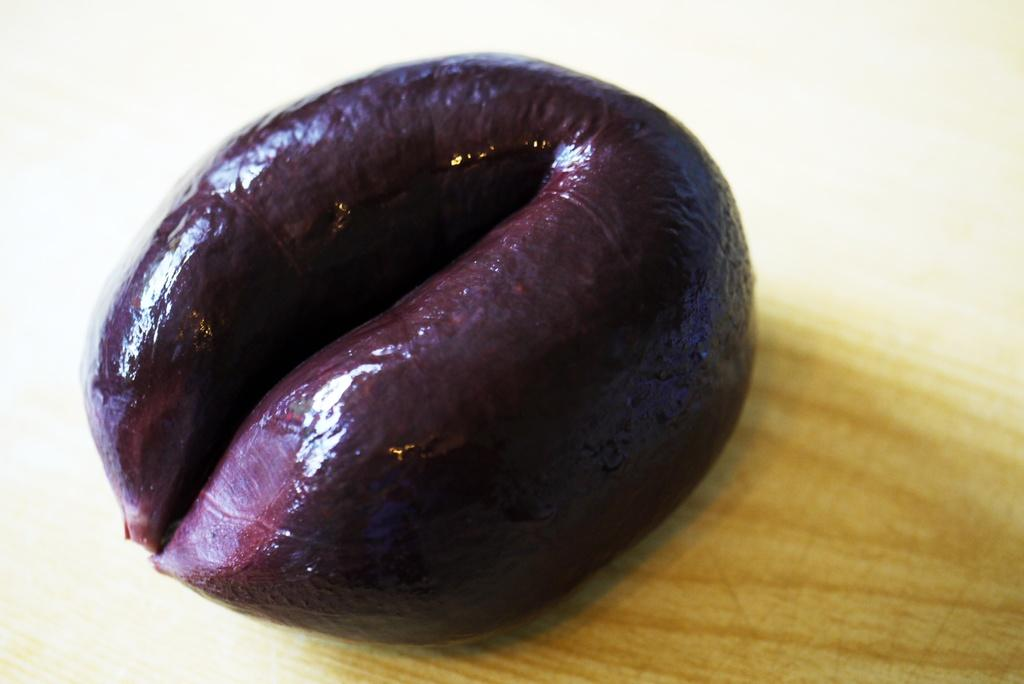What is the main subject of the image? There is an object in the image. Where is the object located? The object is placed on a table. How is the object positioned in the image? The object is in the center of the image. What type of arithmetic problem is being solved on the table in the image? There is no arithmetic problem visible in the image; it only shows an object placed on a table. How many shoes are present in the image? There are no shoes present in the image; it only shows an object placed on a table. 